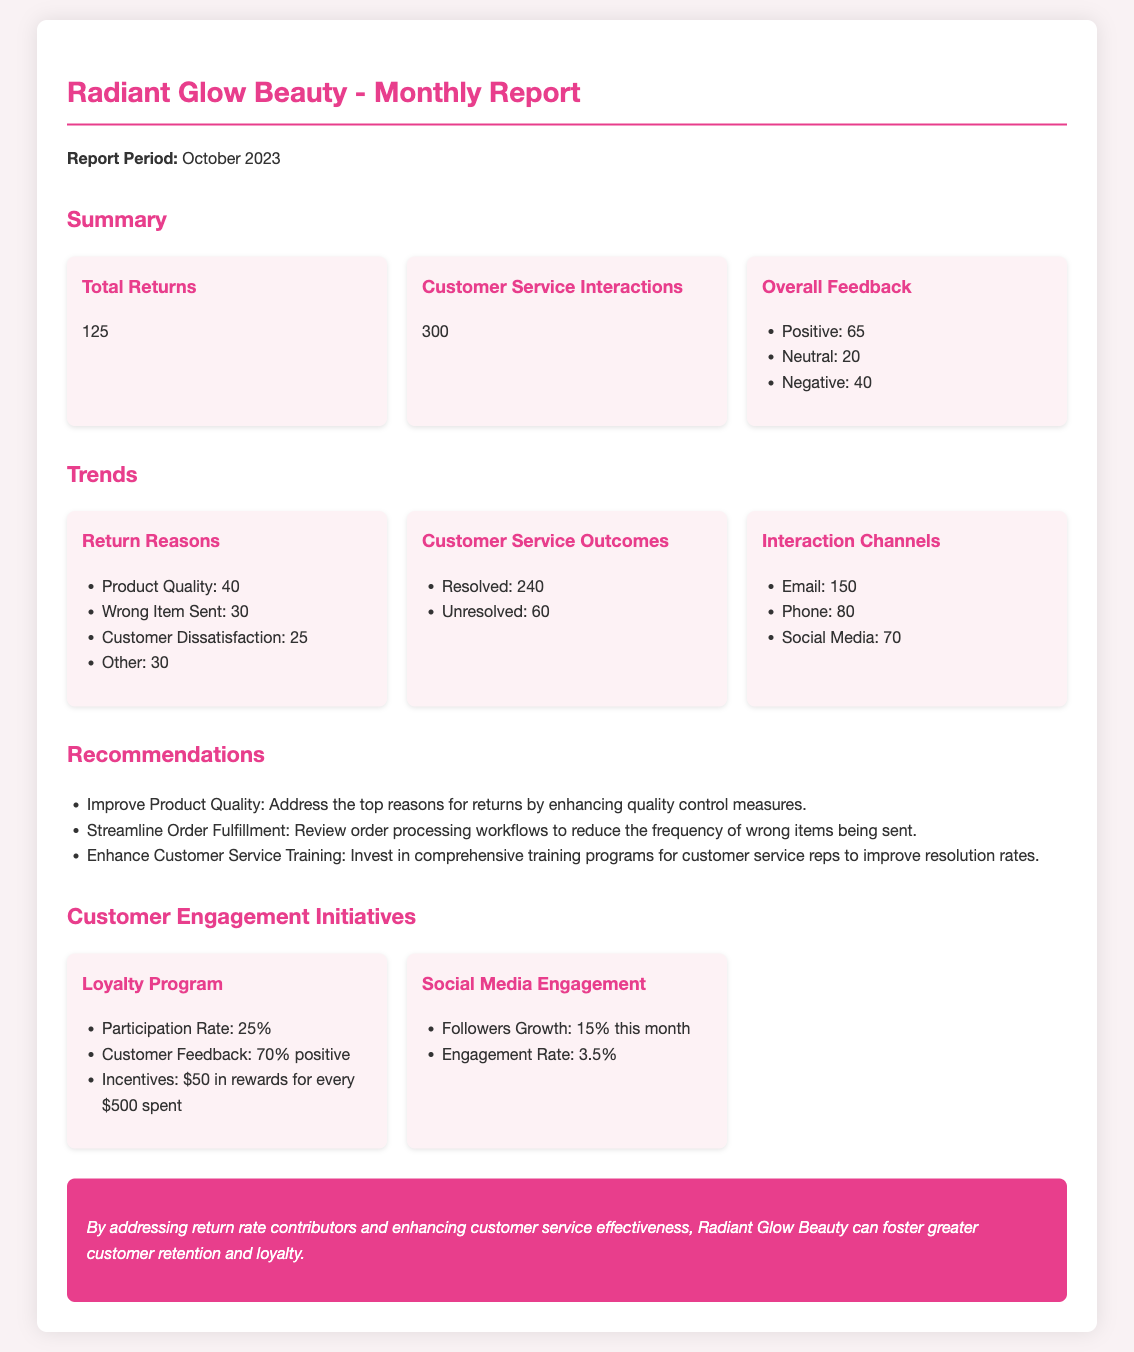What is the total number of product returns? The total number of product returns is mentioned in the summary section of the document.
Answer: 125 How many customer service interactions were recorded? The number of customer service interactions is found in the summary section.
Answer: 300 What is the most common reason for product returns? The reasons for returns are listed in the trends section, with product quality being the most prevalent.
Answer: Product Quality How many customer service outcomes were resolved? The resolved customer service outcomes are provided in the trends section.
Answer: 240 What percentage of loyalty program participants reported positive feedback? The customer feedback percentage for the loyalty program is stated in the customer engagement initiatives section.
Answer: 70% Which channel had the highest customer service interactions? The interaction channels are outlined in the trends section, with email leading in interactions.
Answer: Email What is the engagement rate for social media? The engagement rate can be found under the social media engagement initiatives in the document.
Answer: 3.5% What recommendation is given to improve product returns? The recommendations section lists strategies to address returns, including improving product quality.
Answer: Improve Product Quality What is the participation rate in the loyalty program? The participation rate for the loyalty program is mentioned in the customer engagement initiatives section.
Answer: 25% 